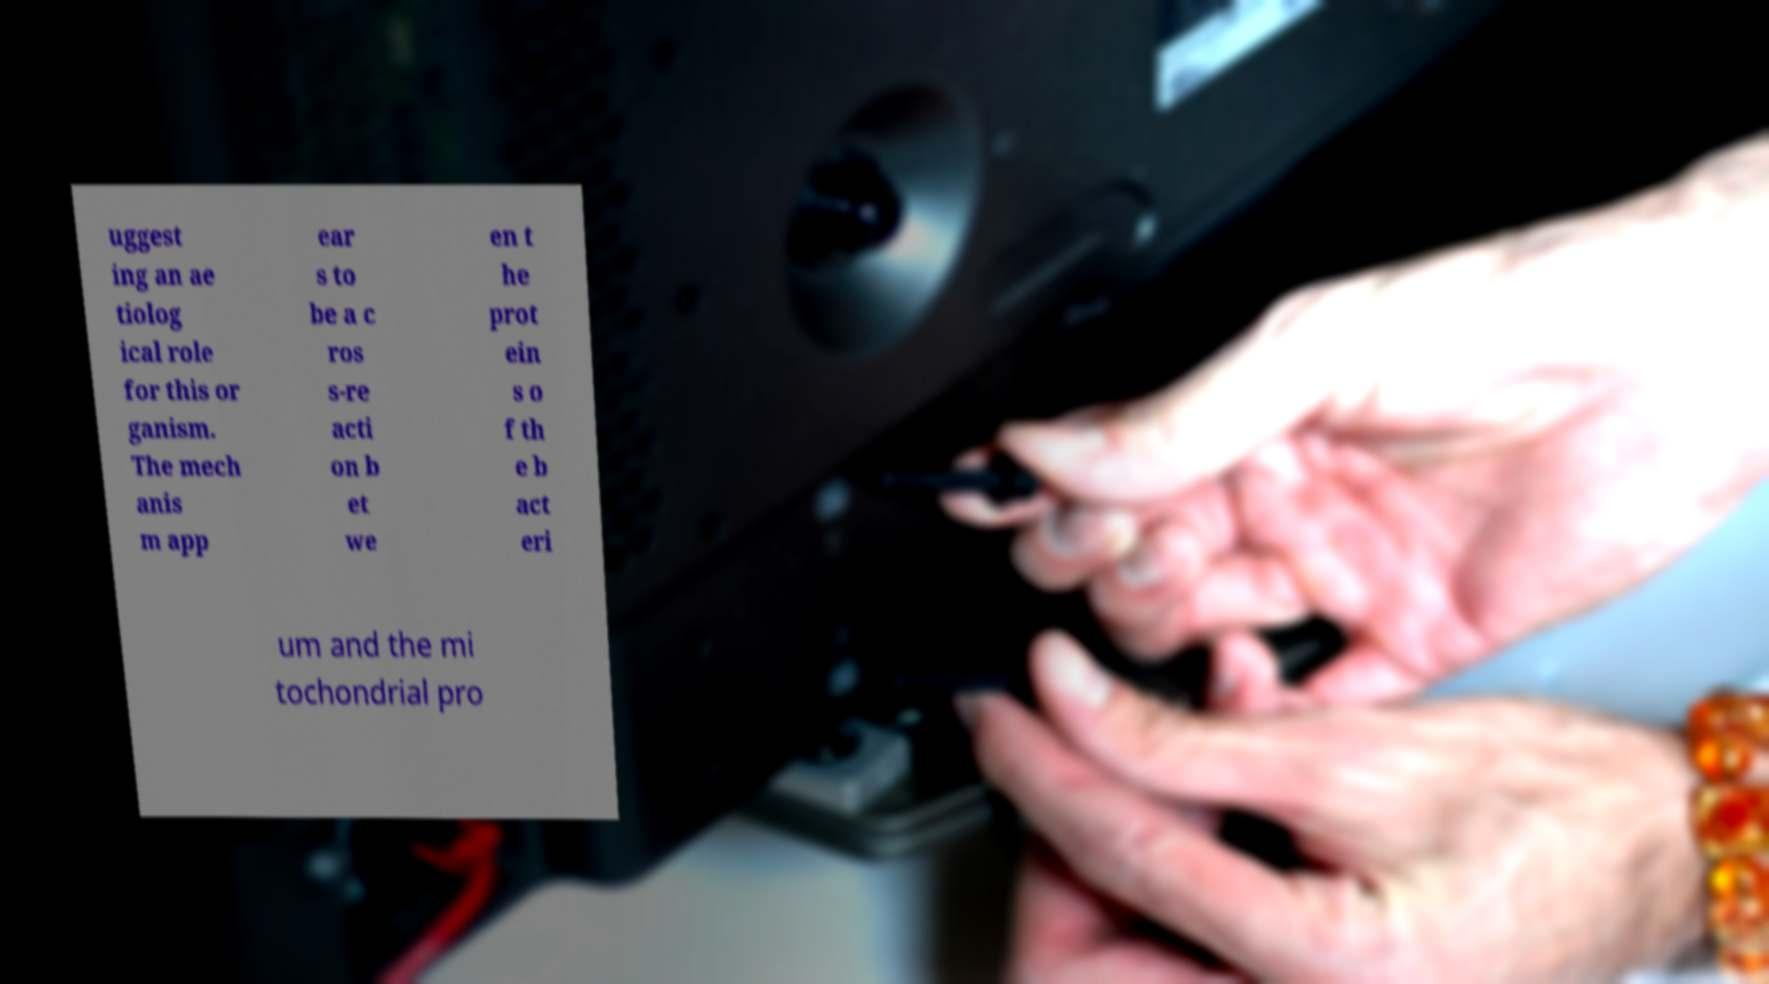What messages or text are displayed in this image? I need them in a readable, typed format. uggest ing an ae tiolog ical role for this or ganism. The mech anis m app ear s to be a c ros s-re acti on b et we en t he prot ein s o f th e b act eri um and the mi tochondrial pro 